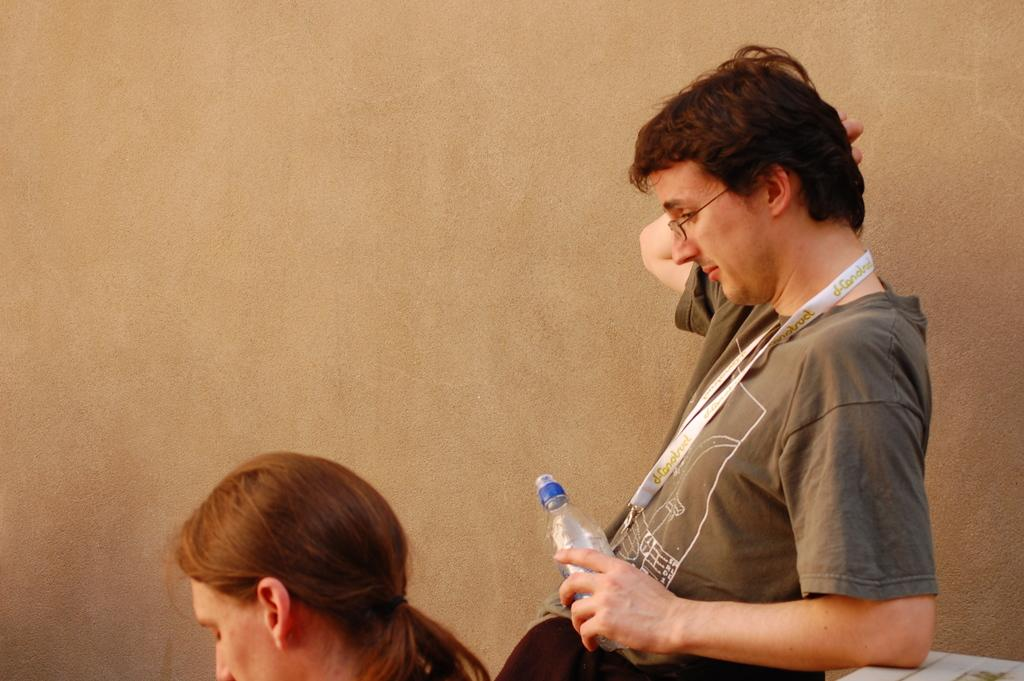What is the position of the man in the image? The man is standing in the image. What is the man holding in his hand? The man is holding a bottle in his hand. What is the position of the woman in the image? The woman is seated in the image. What type of plane can be seen flying in the image? There is no plane visible in the image. What is the cause of death for the person in the image? There is no indication of death or any deceased person in the image. 